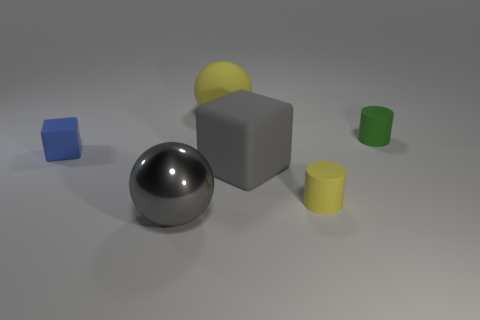There is a yellow object behind the matte thing to the right of the small rubber cylinder that is in front of the tiny blue thing; what is its material?
Make the answer very short. Rubber. There is another rubber object that is the same shape as the blue object; what color is it?
Your answer should be very brief. Gray. How many tiny rubber objects are the same color as the large rubber sphere?
Provide a short and direct response. 1. Is the number of rubber cylinders in front of the small green rubber cylinder greater than the number of red things?
Your response must be concise. Yes. What is the color of the small thing that is left of the large object in front of the yellow rubber cylinder?
Your response must be concise. Blue. What number of objects are large gray things that are on the right side of the large gray metallic ball or rubber things that are to the right of the small yellow object?
Provide a short and direct response. 2. What color is the rubber sphere?
Provide a succinct answer. Yellow. How many tiny green cylinders have the same material as the green object?
Your answer should be compact. 0. Are there more large yellow matte objects than big spheres?
Your response must be concise. No. There is a sphere in front of the tiny green cylinder; what number of yellow rubber balls are in front of it?
Your answer should be very brief. 0. 